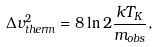<formula> <loc_0><loc_0><loc_500><loc_500>\Delta v ^ { 2 } _ { t h e r m } = 8 \ln 2 \frac { k T _ { K } } { m _ { o b s } } ,</formula> 